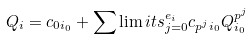Convert formula to latex. <formula><loc_0><loc_0><loc_500><loc_500>Q _ { i } = c _ { 0 i _ { 0 } } + \sum \lim i t s _ { j = 0 } ^ { e _ { i } } c _ { p ^ { j } i _ { 0 } } Q _ { i _ { 0 } } ^ { p ^ { j } }</formula> 